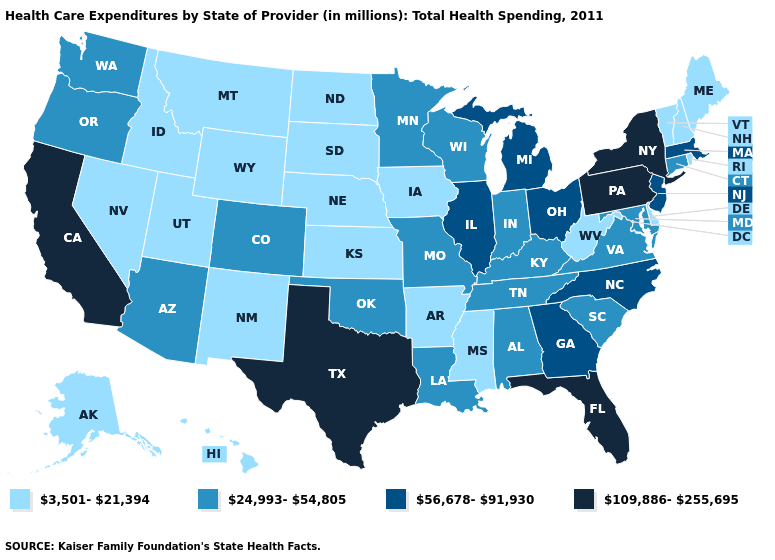Does Oregon have a lower value than Mississippi?
Short answer required. No. What is the lowest value in the USA?
Concise answer only. 3,501-21,394. Name the states that have a value in the range 56,678-91,930?
Answer briefly. Georgia, Illinois, Massachusetts, Michigan, New Jersey, North Carolina, Ohio. Name the states that have a value in the range 3,501-21,394?
Short answer required. Alaska, Arkansas, Delaware, Hawaii, Idaho, Iowa, Kansas, Maine, Mississippi, Montana, Nebraska, Nevada, New Hampshire, New Mexico, North Dakota, Rhode Island, South Dakota, Utah, Vermont, West Virginia, Wyoming. Is the legend a continuous bar?
Give a very brief answer. No. Which states have the lowest value in the USA?
Answer briefly. Alaska, Arkansas, Delaware, Hawaii, Idaho, Iowa, Kansas, Maine, Mississippi, Montana, Nebraska, Nevada, New Hampshire, New Mexico, North Dakota, Rhode Island, South Dakota, Utah, Vermont, West Virginia, Wyoming. Does Illinois have the highest value in the MidWest?
Short answer required. Yes. Does Connecticut have the highest value in the USA?
Concise answer only. No. Does Tennessee have the highest value in the USA?
Quick response, please. No. What is the highest value in the South ?
Write a very short answer. 109,886-255,695. Name the states that have a value in the range 24,993-54,805?
Quick response, please. Alabama, Arizona, Colorado, Connecticut, Indiana, Kentucky, Louisiana, Maryland, Minnesota, Missouri, Oklahoma, Oregon, South Carolina, Tennessee, Virginia, Washington, Wisconsin. What is the highest value in the USA?
Give a very brief answer. 109,886-255,695. Which states have the lowest value in the West?
Concise answer only. Alaska, Hawaii, Idaho, Montana, Nevada, New Mexico, Utah, Wyoming. Which states have the highest value in the USA?
Keep it brief. California, Florida, New York, Pennsylvania, Texas. What is the lowest value in the USA?
Answer briefly. 3,501-21,394. 